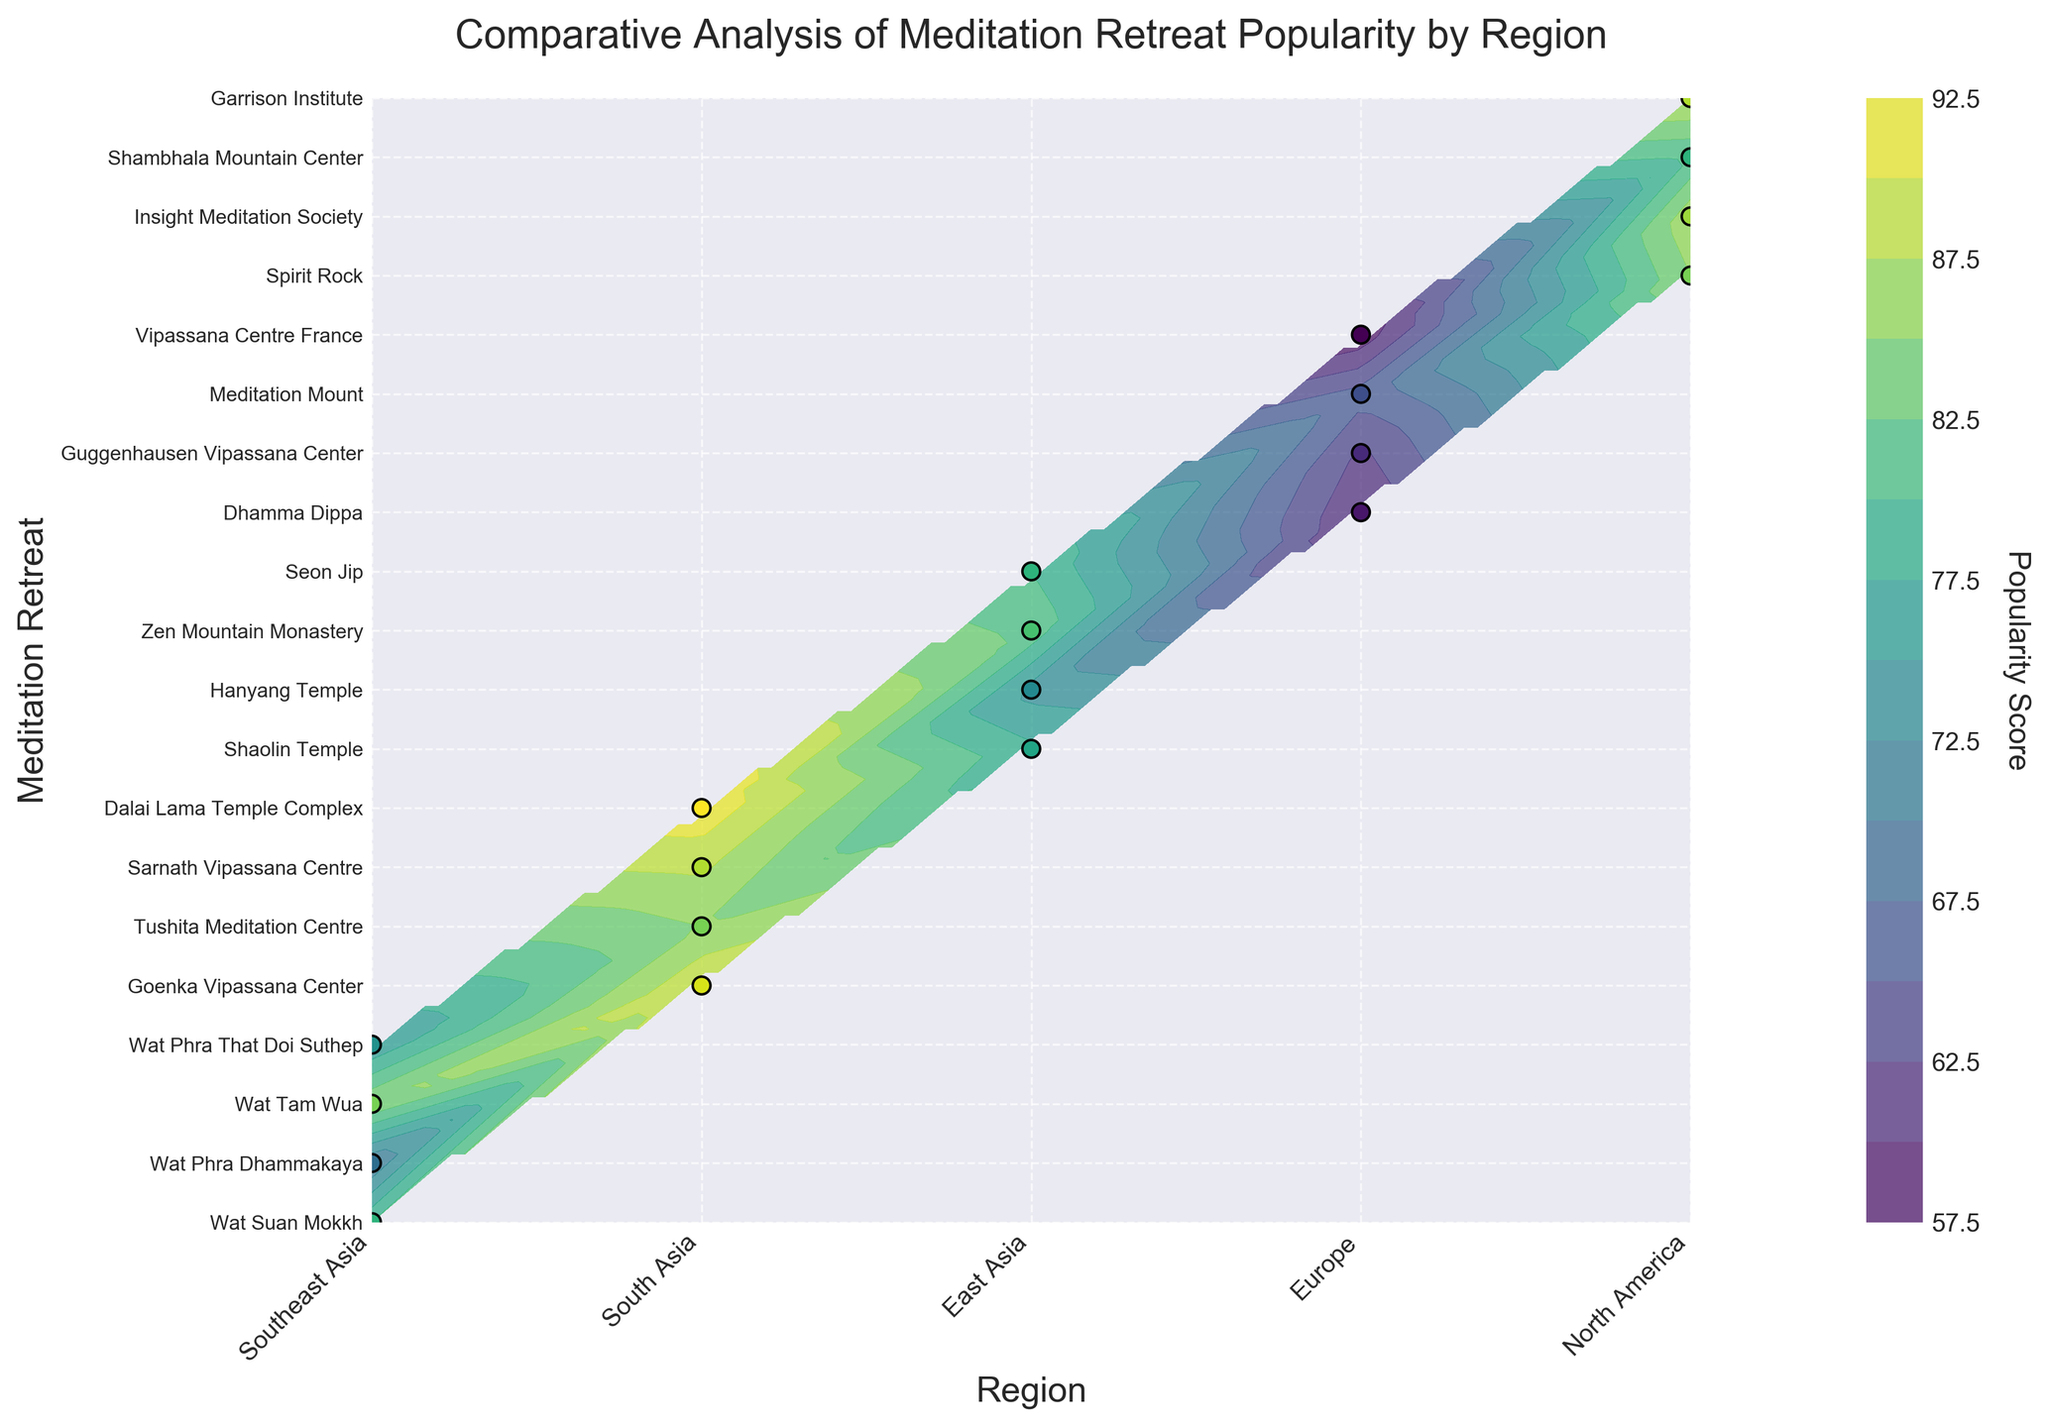What's the title of the plot? The title of the plot is always located at the top center of the figure and is designed to give a clear indication of what the plot is about. From the information provided, the title is likely descriptive of the contents.
Answer: Comparative Analysis of Meditation Retreat Popularity by Region Which region has the highest popularity score? To find the region with the highest popularity score, look for the peak value on the color bar and the corresponding region on the x-axis. South Asia appears to have the highest scores.
Answer: South Asia How many meditation retreats are listed for Southeast Asia? To find out how many retreats are listed for Southeast Asia, count the number of y-axis labels that belong to this region.
Answer: 4 What is the popularity score of the Dalai Lama Temple Complex? The specific y-axis label for the Dalai Lama Temple Complex will indicate its position on the y-axis. Trace the corresponding contour level to determine its popularity score.
Answer: 92 Compare the popularity scores of the top retreat in Southeast Asia and the top retreat in South Asia. Which is higher? Identify the highest scores for both regions from the y-axis labels and color contour levels. Wat Tam Wua in Southeast Asia has 85, while Dalai Lama Temple Complex in South Asia has 92.
Answer: South Asia Which two North American retreats have the highest and lowest popularity scores, and what are their scores? Examine the y-axis for North American retreats and check their popularity scores from the contour levels. Spirit Rock (85) and Shambhala Mountain Center (80).
Answer: Spirit Rock: 85, Shambhala Mountain Center: 80 By how much is the popularity score of Garrison Institute higher than Vipassana Centre France? Compare the contour levels of Garrison Institute and Vipassana Centre France to calculate the difference. Garrison Institute (88) and Vipassana Centre France (58).
Answer: 30 What region has the lowest average popularity score? Calculate the average popularity score for each region by summing the scores and dividing by the number of retreats in that region. Identify the region with the lowest value.
Answer: Europe Which retreat in East Asia is the most popular? Check the retreats listed under the East Asia region and identify the highest contour level or data point. Zen Mountain Monastery has the highest score.
Answer: Zen Mountain Monastery What can you infer about the overall popularity trends among the regions? Observe the color gradients and distribution of scores across regions. South Asia generally has higher popularity scores, while Europe has lower scores. Trends indicate higher popularity in Asian regions.
Answer: Higher in South and Southeast Asia, lower in Europe 